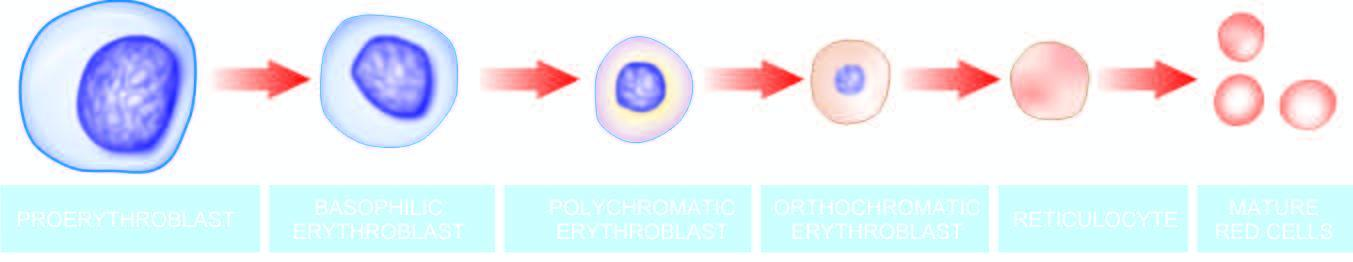does the circle shown with red line contain progressively less rna and more haemoglobin?
Answer the question using a single word or phrase. No 